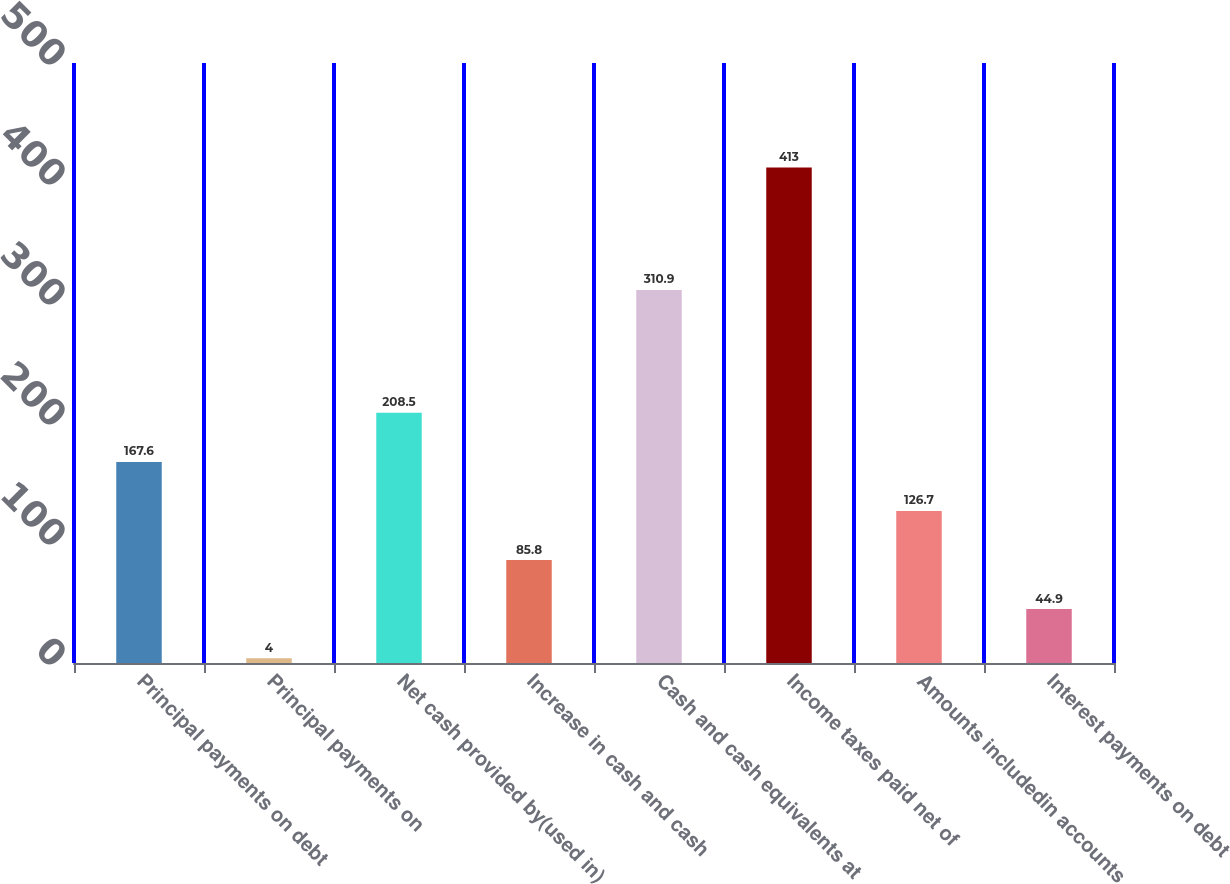Convert chart. <chart><loc_0><loc_0><loc_500><loc_500><bar_chart><fcel>Principal payments on debt<fcel>Principal payments on<fcel>Net cash provided by(used in)<fcel>Increase in cash and cash<fcel>Cash and cash equivalents at<fcel>Income taxes paid net of<fcel>Amounts includedin accounts<fcel>Interest payments on debt<nl><fcel>167.6<fcel>4<fcel>208.5<fcel>85.8<fcel>310.9<fcel>413<fcel>126.7<fcel>44.9<nl></chart> 